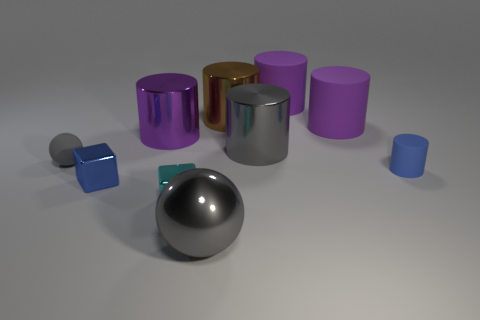Subtract all cyan blocks. How many purple cylinders are left? 3 Subtract all brown cylinders. How many cylinders are left? 5 Subtract 2 cylinders. How many cylinders are left? 4 Subtract all blue rubber cylinders. How many cylinders are left? 5 Subtract all blue cylinders. Subtract all blue cubes. How many cylinders are left? 5 Subtract all blocks. How many objects are left? 8 Subtract all large metallic cylinders. Subtract all large matte cylinders. How many objects are left? 5 Add 4 gray shiny things. How many gray shiny things are left? 6 Add 1 shiny blocks. How many shiny blocks exist? 3 Subtract 0 blue spheres. How many objects are left? 10 